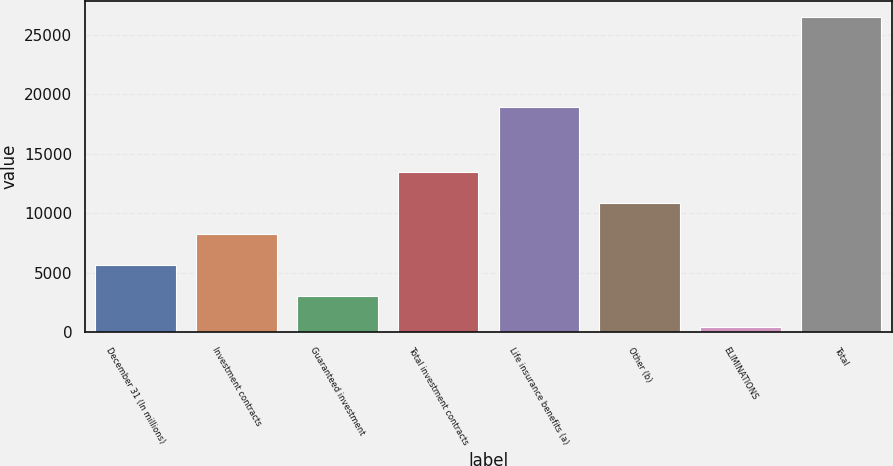<chart> <loc_0><loc_0><loc_500><loc_500><bar_chart><fcel>December 31 (In millions)<fcel>Investment contracts<fcel>Guaranteed investment<fcel>Total investment contracts<fcel>Life insurance benefits (a)<fcel>Other (b)<fcel>ELIMINATIONS<fcel>Total<nl><fcel>5656.8<fcel>8267.7<fcel>3045.9<fcel>13489.5<fcel>18959<fcel>10878.6<fcel>435<fcel>26544<nl></chart> 